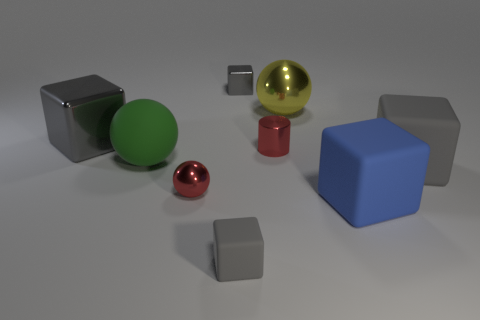Is the number of gray things on the right side of the small gray matte block the same as the number of gray metal things on the right side of the red cylinder?
Keep it short and to the point. No. How many red objects are big blocks or large matte spheres?
Give a very brief answer. 0. Is the color of the metallic cylinder the same as the sphere in front of the green sphere?
Provide a succinct answer. Yes. How many other objects are the same color as the tiny shiny cube?
Your answer should be compact. 3. Are there fewer metallic cubes than red cylinders?
Your answer should be very brief. No. There is a small gray block that is on the right side of the matte block that is on the left side of the small gray metal block; how many big yellow spheres are behind it?
Ensure brevity in your answer.  0. There is a gray matte object on the right side of the large yellow ball; what size is it?
Offer a terse response. Large. There is a big blue matte thing right of the big gray metallic cube; is it the same shape as the tiny matte thing?
Your answer should be very brief. Yes. There is another big object that is the same shape as the big green object; what material is it?
Offer a very short reply. Metal. Is there a purple block?
Provide a short and direct response. No. 